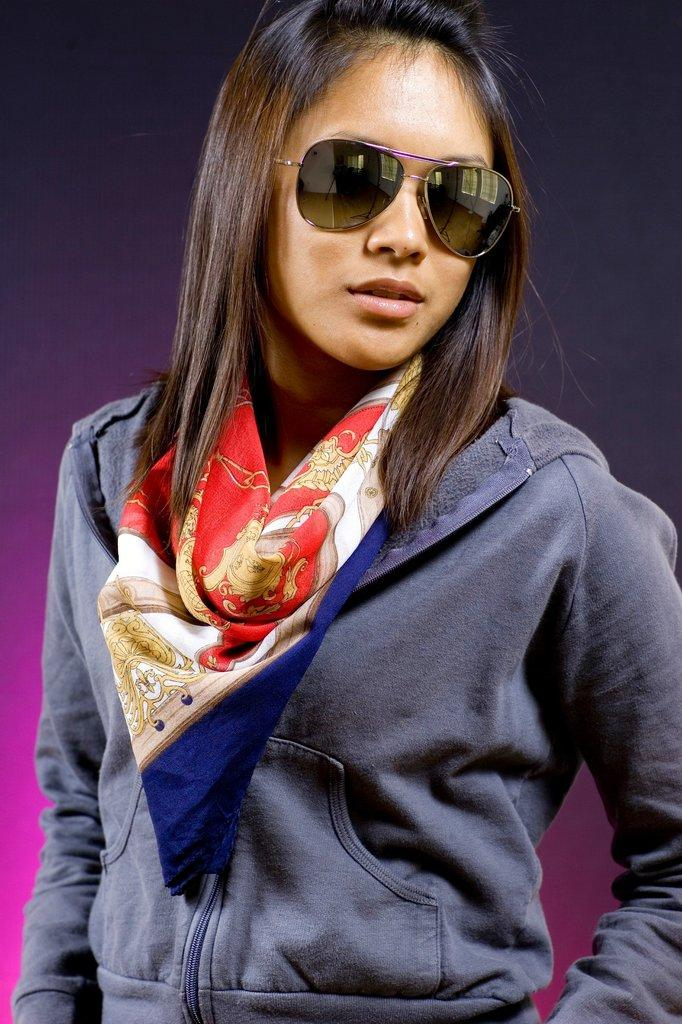Who is the main subject in the image? There is a girl in the middle of the image. What is the girl wearing on her upper body? The girl is wearing a sweater. What type of eyewear is the girl wearing? The girl is wearing goggles. How many snakes are wrapped around the girl's legs in the image? There are no snakes present in the image. What type of coat is the girl wearing over her sweater in the image? The girl is not wearing a coat in the image; she is only wearing a sweater. 